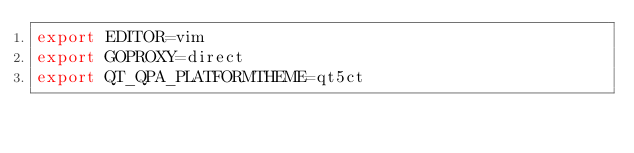<code> <loc_0><loc_0><loc_500><loc_500><_Bash_>export EDITOR=vim
export GOPROXY=direct
export QT_QPA_PLATFORMTHEME=qt5ct
</code> 